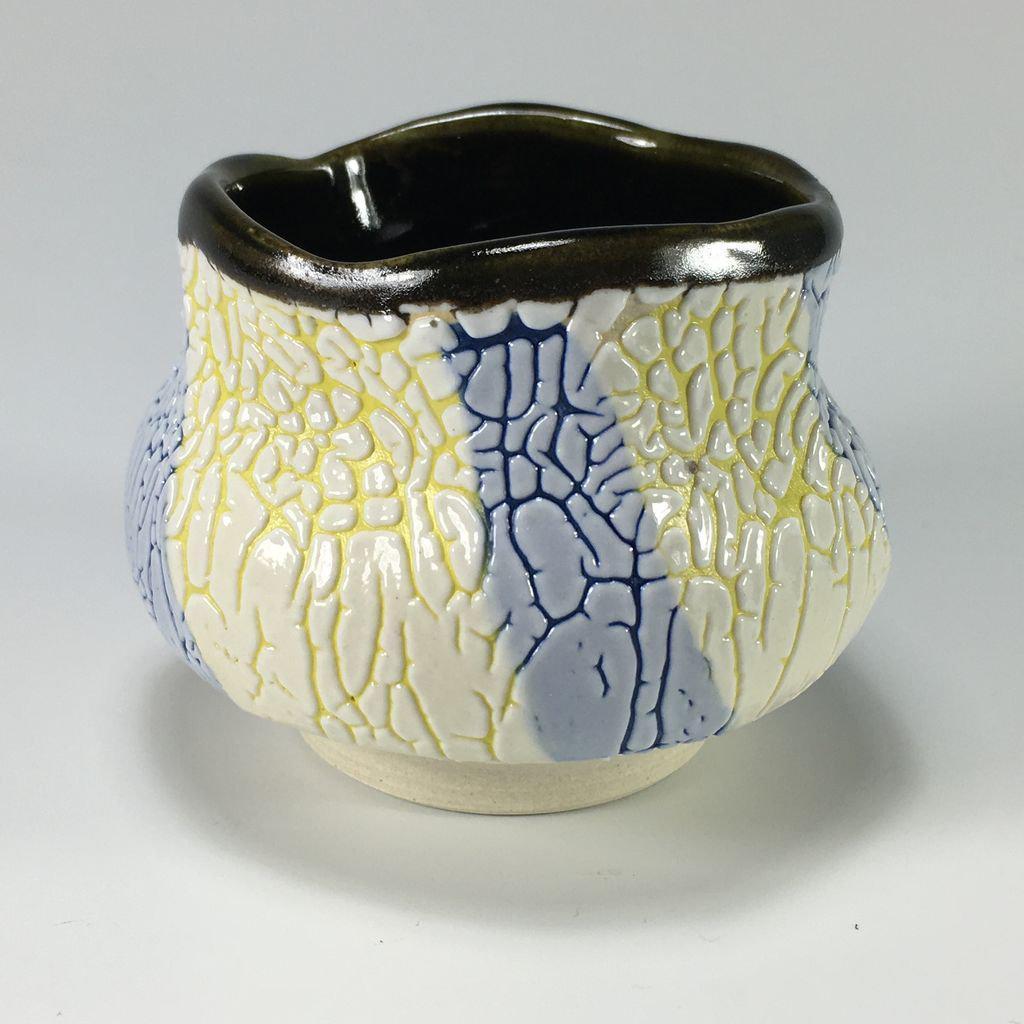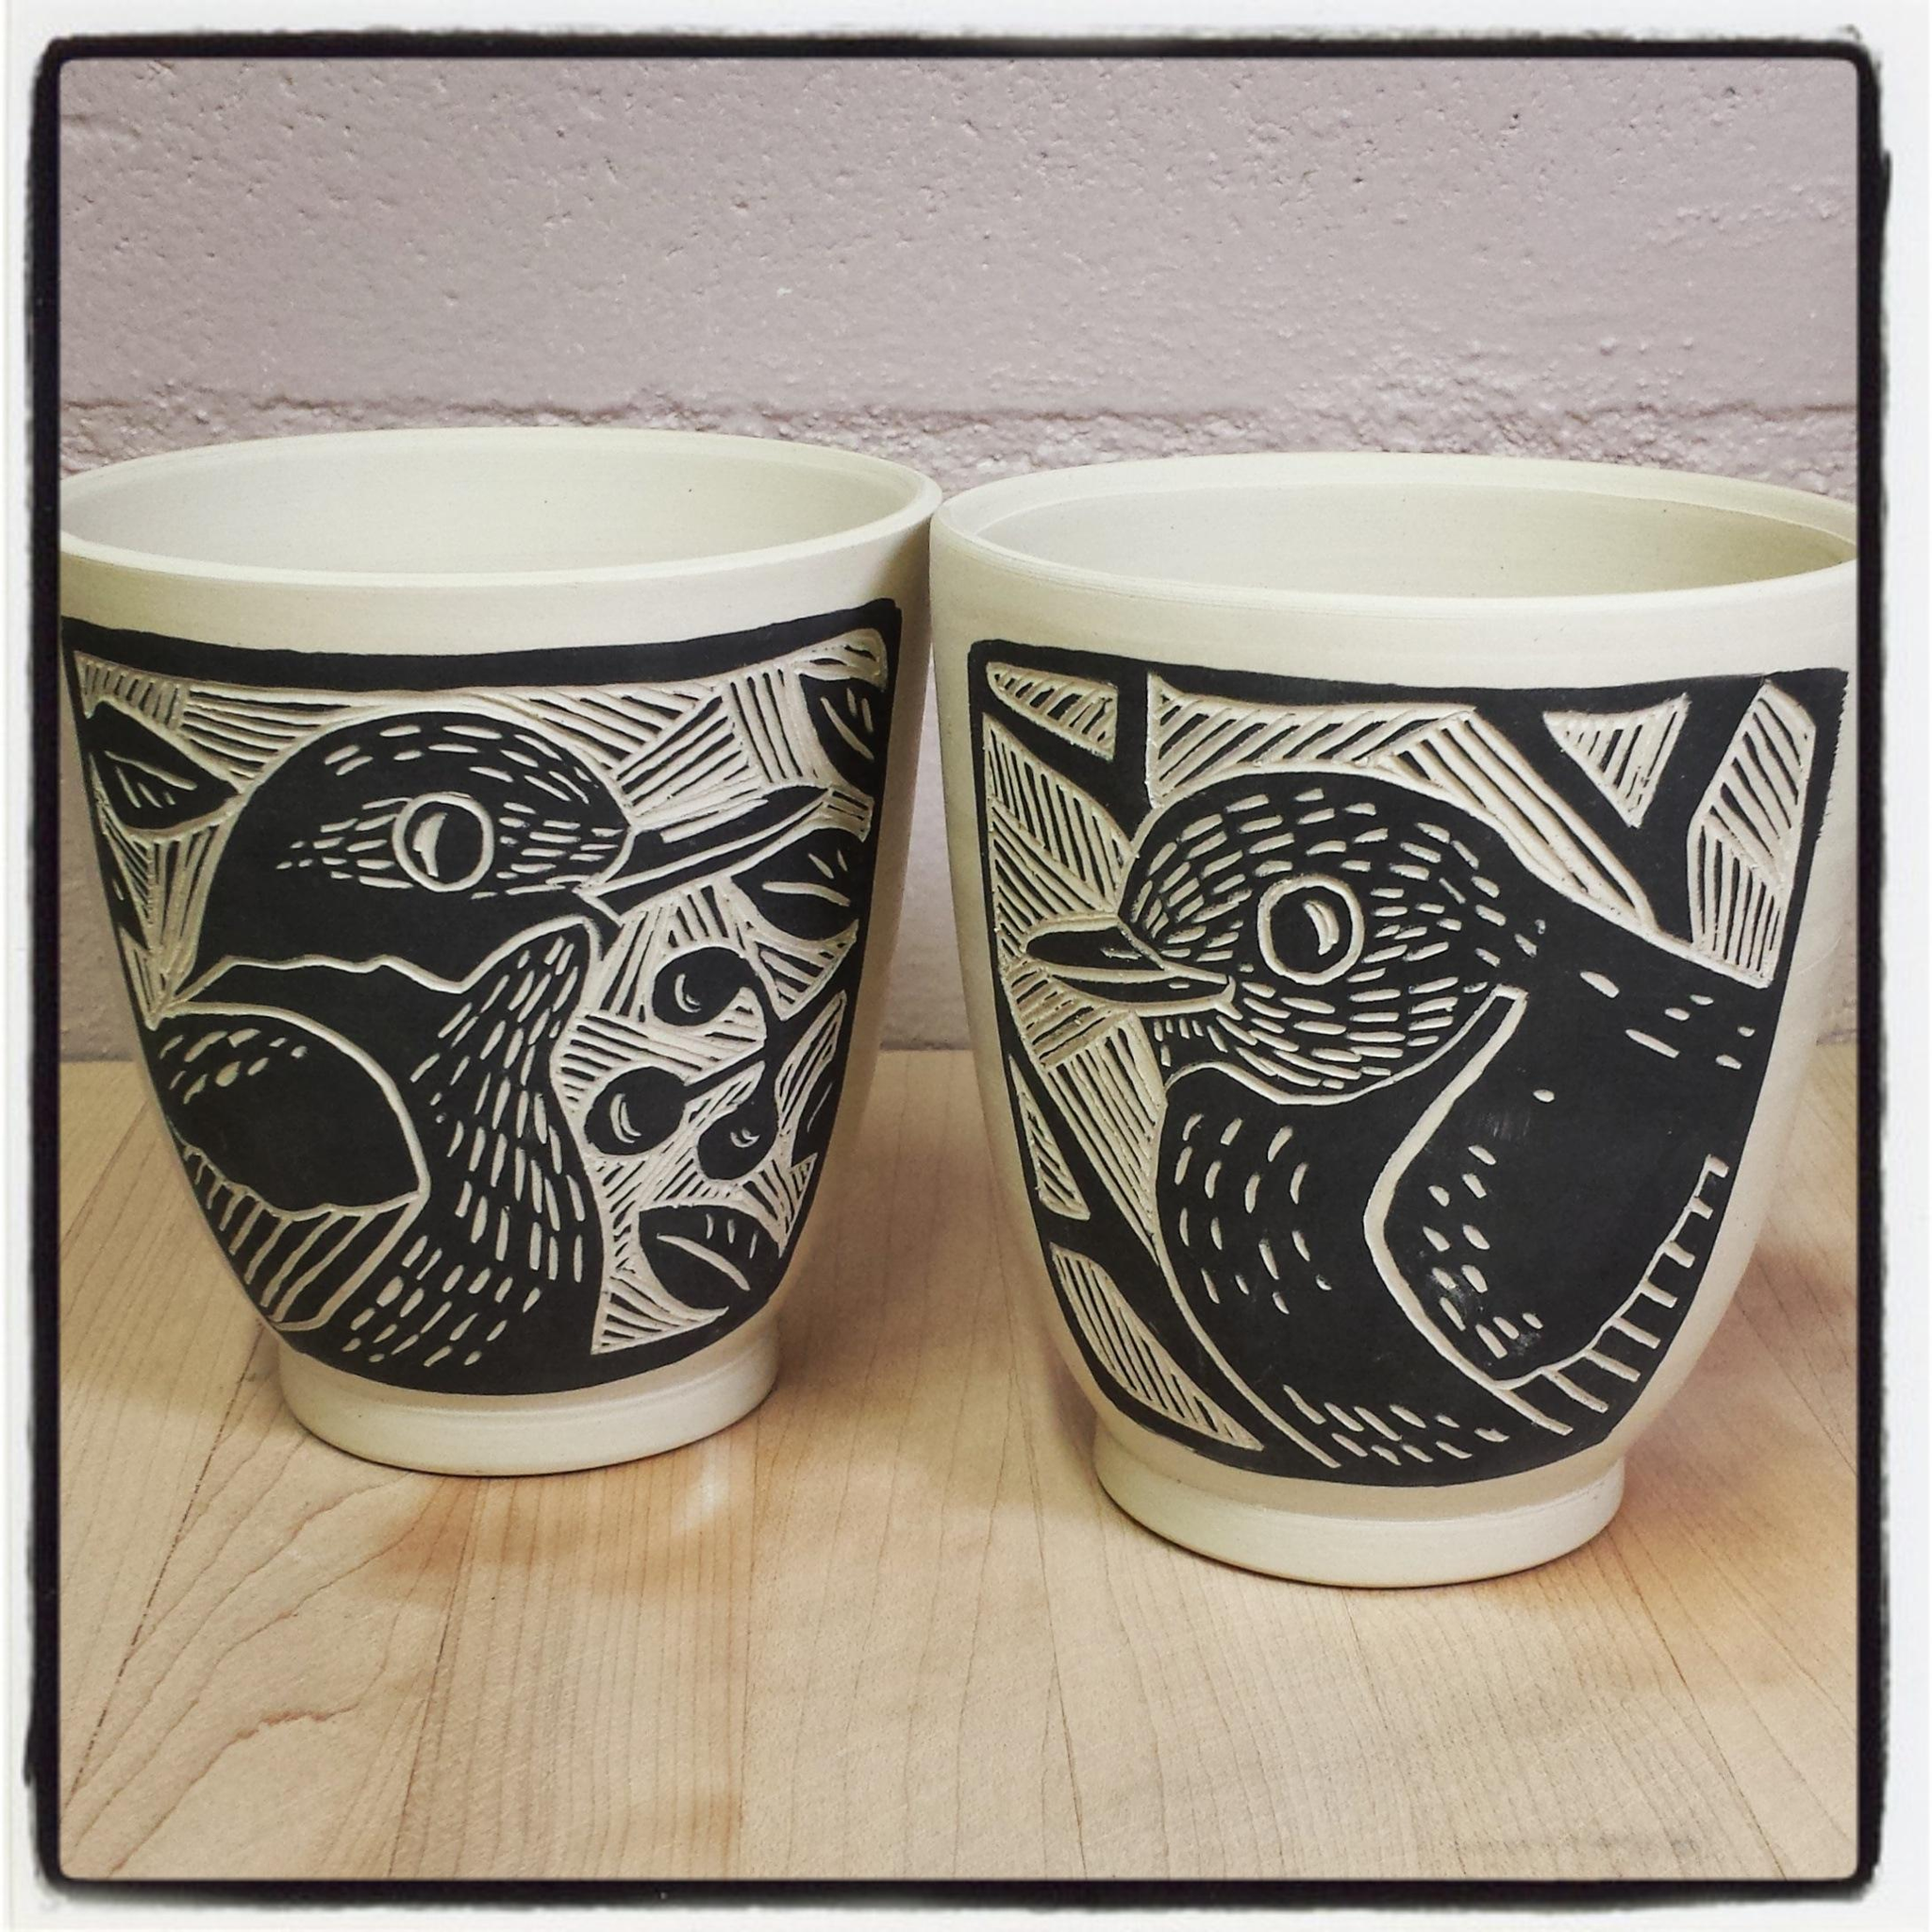The first image is the image on the left, the second image is the image on the right. For the images shown, is this caption "The left and right image contains the same number  of cups." true? Answer yes or no. No. The first image is the image on the left, the second image is the image on the right. Examine the images to the left and right. Is the description "There are more than 2 cups." accurate? Answer yes or no. Yes. 